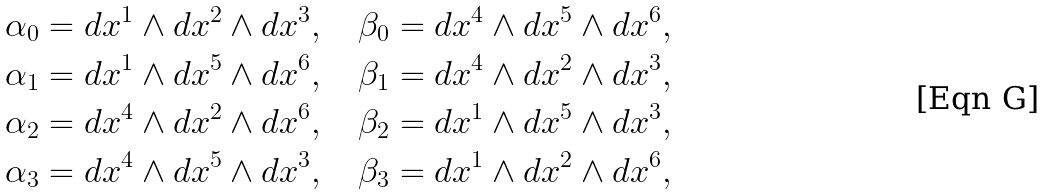<formula> <loc_0><loc_0><loc_500><loc_500>\alpha _ { 0 } = d x ^ { 1 } \wedge d x ^ { 2 } \wedge d x ^ { 3 } , \quad \beta _ { 0 } = d x ^ { 4 } \wedge d x ^ { 5 } \wedge d x ^ { 6 } , \\ \alpha _ { 1 } = d x ^ { 1 } \wedge d x ^ { 5 } \wedge d x ^ { 6 } , \quad \beta _ { 1 } = d x ^ { 4 } \wedge d x ^ { 2 } \wedge d x ^ { 3 } , \\ \alpha _ { 2 } = d x ^ { 4 } \wedge d x ^ { 2 } \wedge d x ^ { 6 } , \quad \beta _ { 2 } = d x ^ { 1 } \wedge d x ^ { 5 } \wedge d x ^ { 3 } , \\ \alpha _ { 3 } = d x ^ { 4 } \wedge d x ^ { 5 } \wedge d x ^ { 3 } , \quad \beta _ { 3 } = d x ^ { 1 } \wedge d x ^ { 2 } \wedge d x ^ { 6 } ,</formula> 